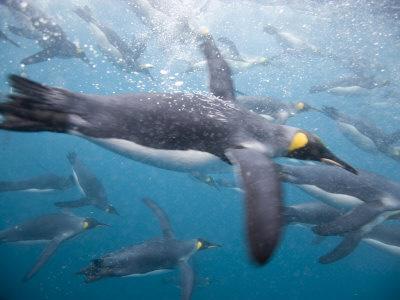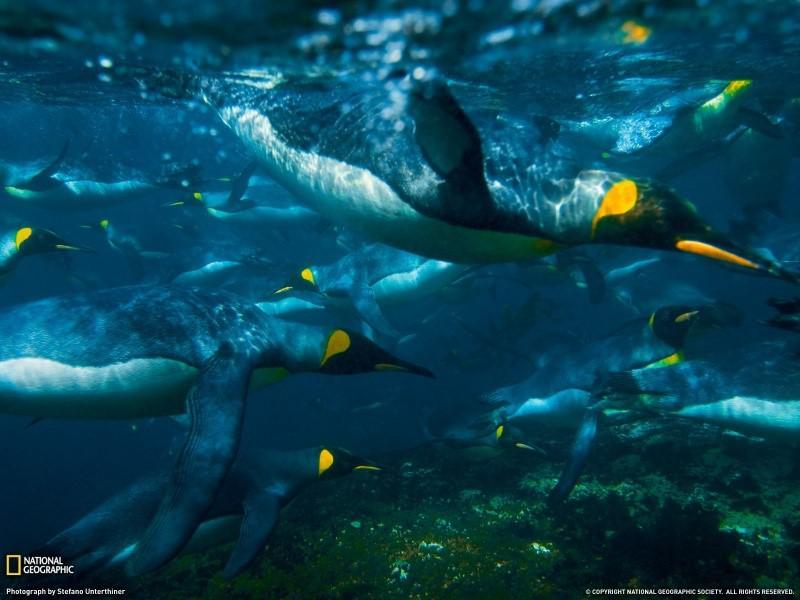The first image is the image on the left, the second image is the image on the right. Assess this claim about the two images: "An image shows multiple penguins swimming underwater where no ocean bottom is visible.". Correct or not? Answer yes or no. Yes. The first image is the image on the left, the second image is the image on the right. Examine the images to the left and right. Is the description "There are no more than 2 penguins in one of the images." accurate? Answer yes or no. No. 